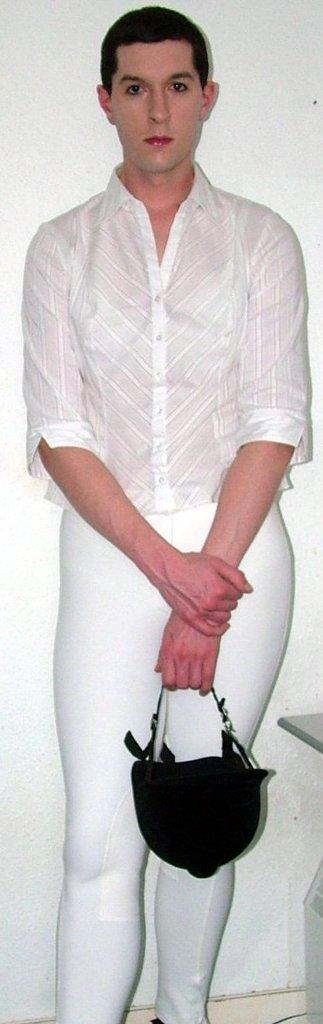What can be seen in the image? There is a person in the image. Can you describe the person's attire? The person is wearing a white dress. What object is the person holding in their hands? The person is holding a black helmet in their hands. What type of canvas is being used to stop the person in the image? There is no canvas or indication of stopping the person in the image. 